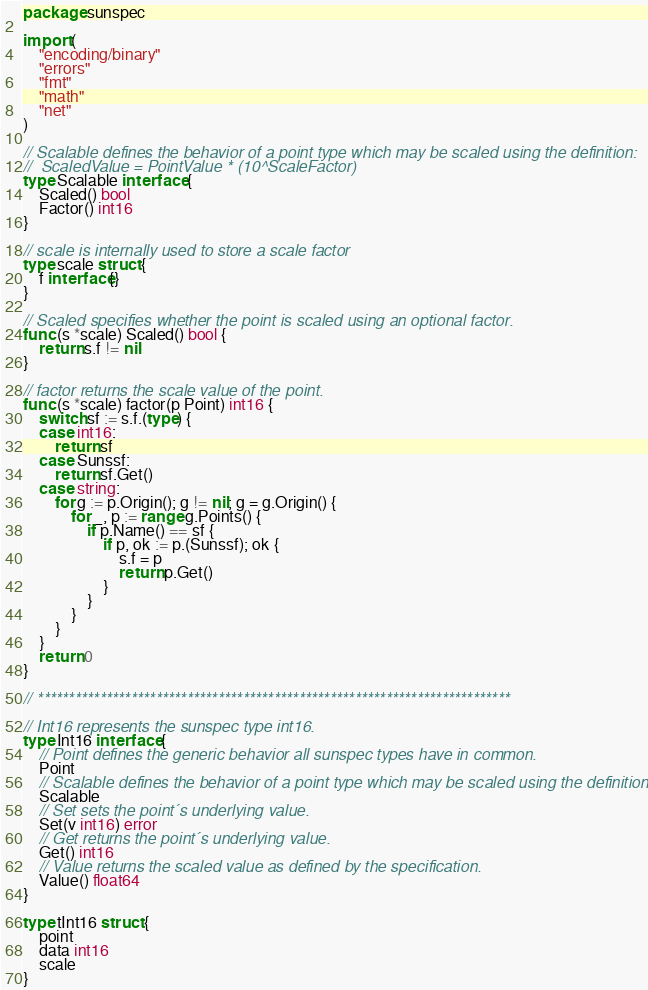<code> <loc_0><loc_0><loc_500><loc_500><_Go_>package sunspec

import (
	"encoding/binary"
	"errors"
	"fmt"
	"math"
	"net"
)

// Scalable defines the behavior of a point type which may be scaled using the definition:
//	ScaledValue = PointValue * (10^ScaleFactor)
type Scalable interface {
	Scaled() bool
	Factor() int16
}

// scale is internally used to store a scale factor
type scale struct {
	f interface{}
}

// Scaled specifies whether the point is scaled using an optional factor.
func (s *scale) Scaled() bool {
	return s.f != nil
}

// factor returns the scale value of the point.
func (s *scale) factor(p Point) int16 {
	switch sf := s.f.(type) {
	case int16:
		return sf
	case Sunssf:
		return sf.Get()
	case string:
		for g := p.Origin(); g != nil; g = g.Origin() {
			for _, p := range g.Points() {
				if p.Name() == sf {
					if p, ok := p.(Sunssf); ok {
						s.f = p
						return p.Get()
					}
				}
			}
		}
	}
	return 0
}

// ****************************************************************************

// Int16 represents the sunspec type int16.
type Int16 interface {
	// Point defines the generic behavior all sunspec types have in common.
	Point
	// Scalable defines the behavior of a point type which may be scaled using the definition.
	Scalable
	// Set sets the point´s underlying value.
	Set(v int16) error
	// Get returns the point´s underlying value.
	Get() int16
	// Value returns the scaled value as defined by the specification.
	Value() float64
}

type tInt16 struct {
	point
	data int16
	scale
}
</code> 